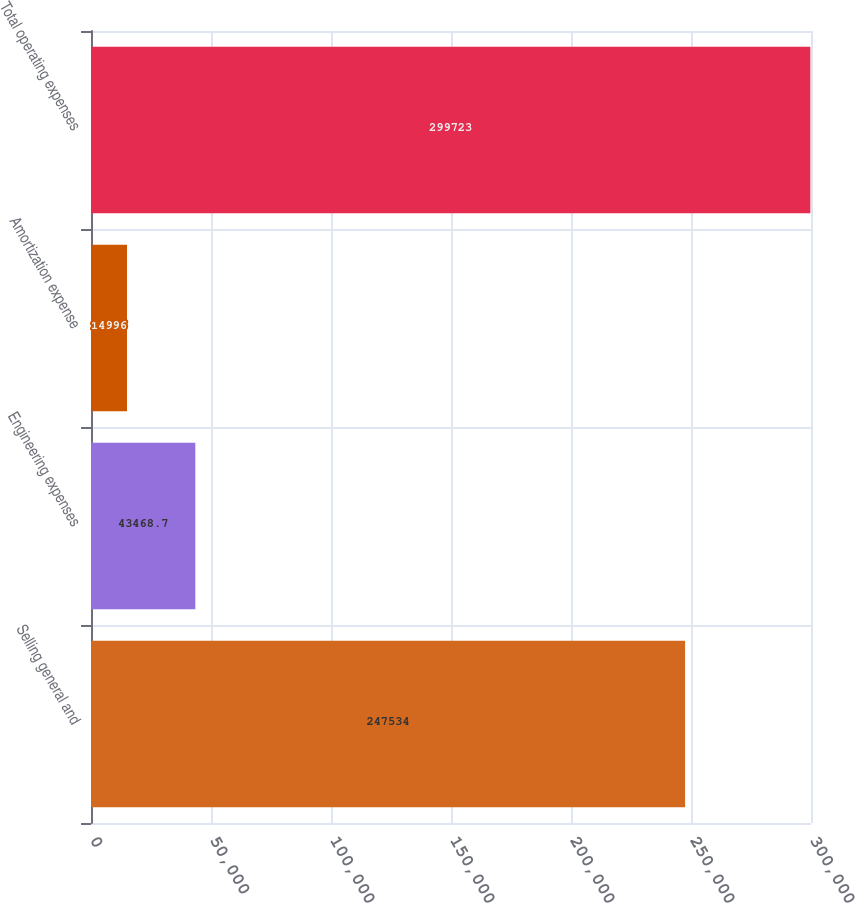<chart> <loc_0><loc_0><loc_500><loc_500><bar_chart><fcel>Selling general and<fcel>Engineering expenses<fcel>Amortization expense<fcel>Total operating expenses<nl><fcel>247534<fcel>43468.7<fcel>14996<fcel>299723<nl></chart> 